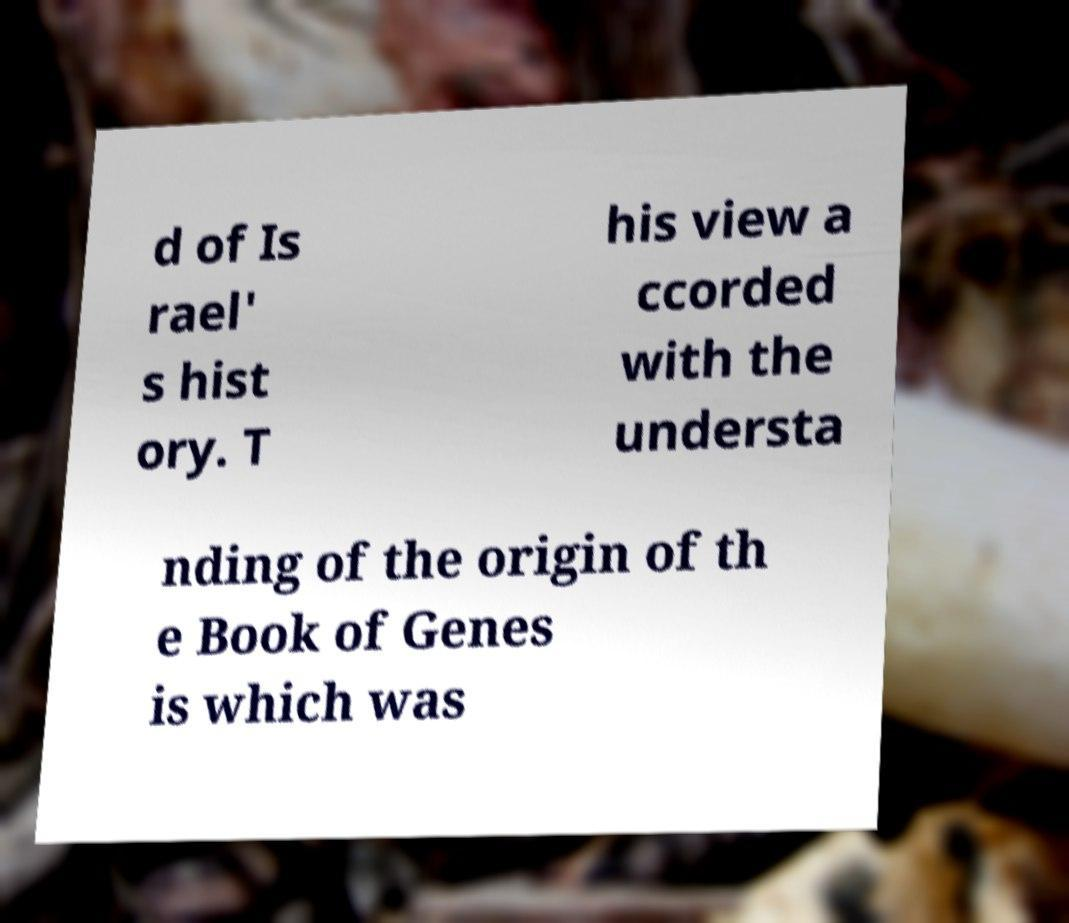Please identify and transcribe the text found in this image. d of Is rael' s hist ory. T his view a ccorded with the understa nding of the origin of th e Book of Genes is which was 